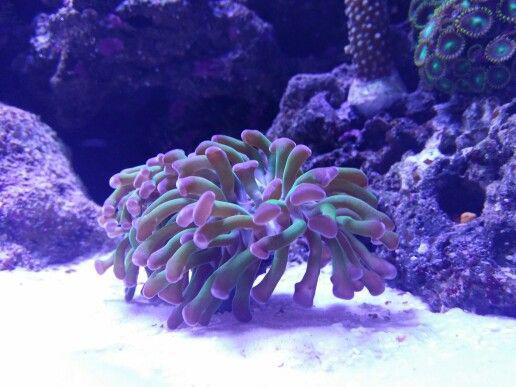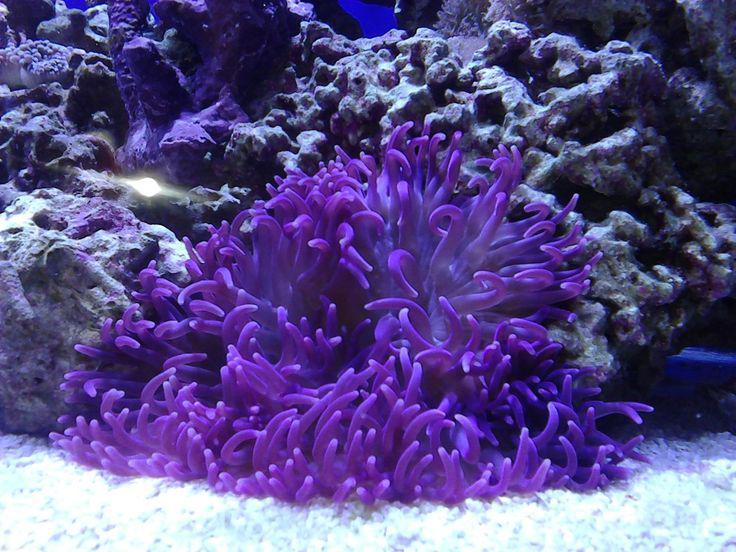The first image is the image on the left, the second image is the image on the right. Analyze the images presented: Is the assertion "At least one sea anemone is pedominantly pink." valid? Answer yes or no. No. The first image is the image on the left, the second image is the image on the right. Examine the images to the left and right. Is the description "One image includes at least one distinctive flower-shaped anemone that stands out from its background, and the other shows a nearly monochromatic scene." accurate? Answer yes or no. No. 